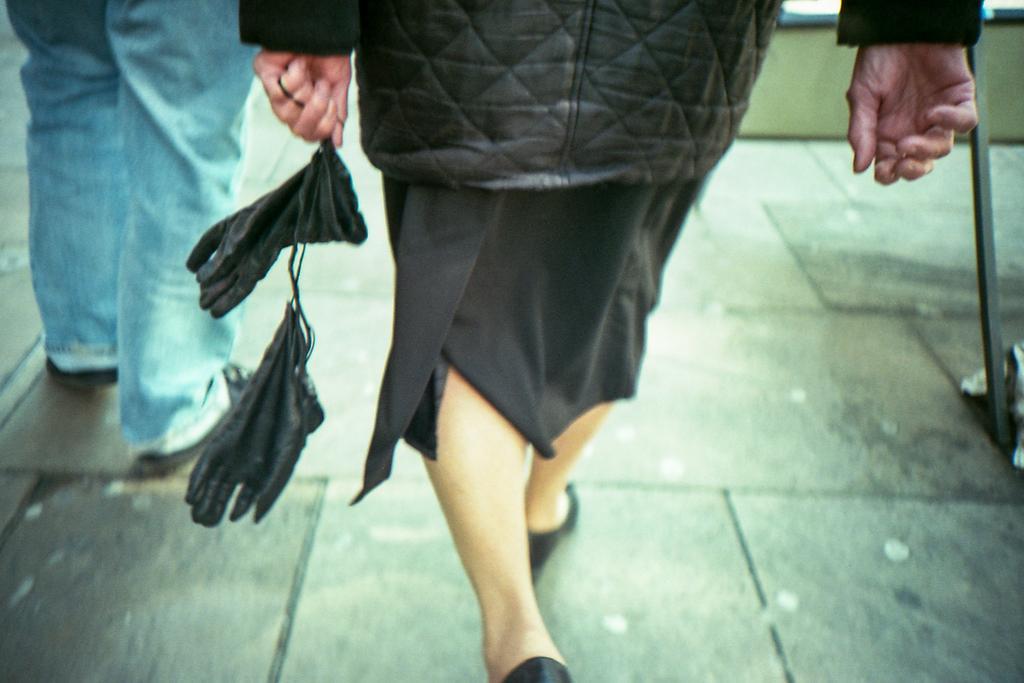In one or two sentences, can you explain what this image depicts? In this picture I can observe a person walking on the floor, holding black color gloves in her hand. On the left side I can observe another person standing on the floor. 